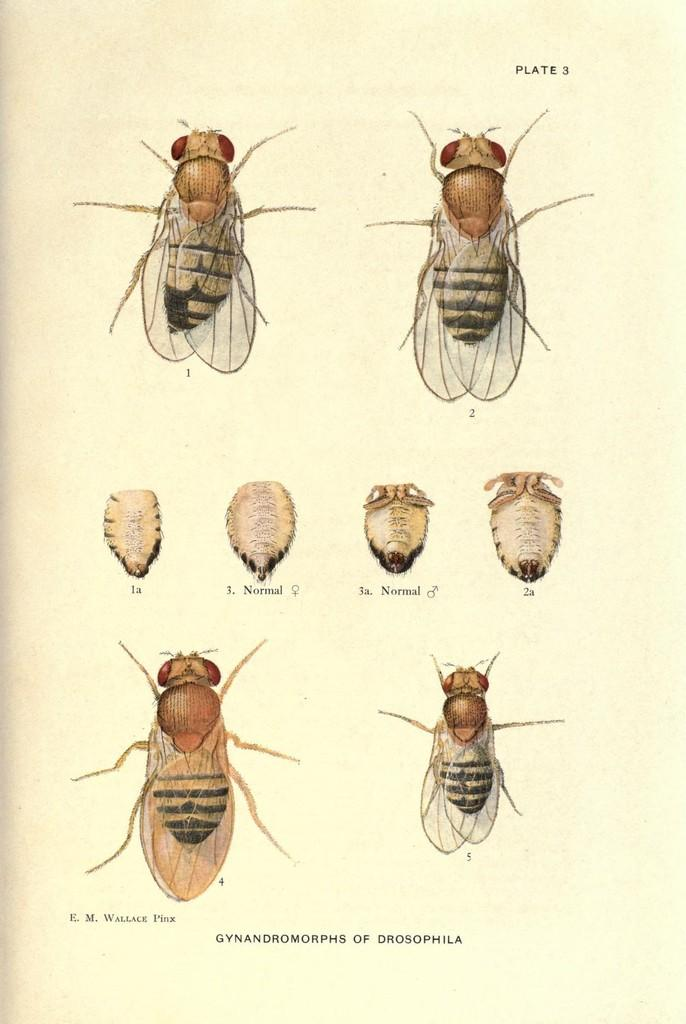What type of creatures are depicted in the images in the picture? There are pictures of insects in the image. Is there any text accompanying the images? Yes, there is text at the bottom of the image. What type of stone is being held by the doll in the image? There is no doll or stone present in the image; it features pictures of insects and text. 